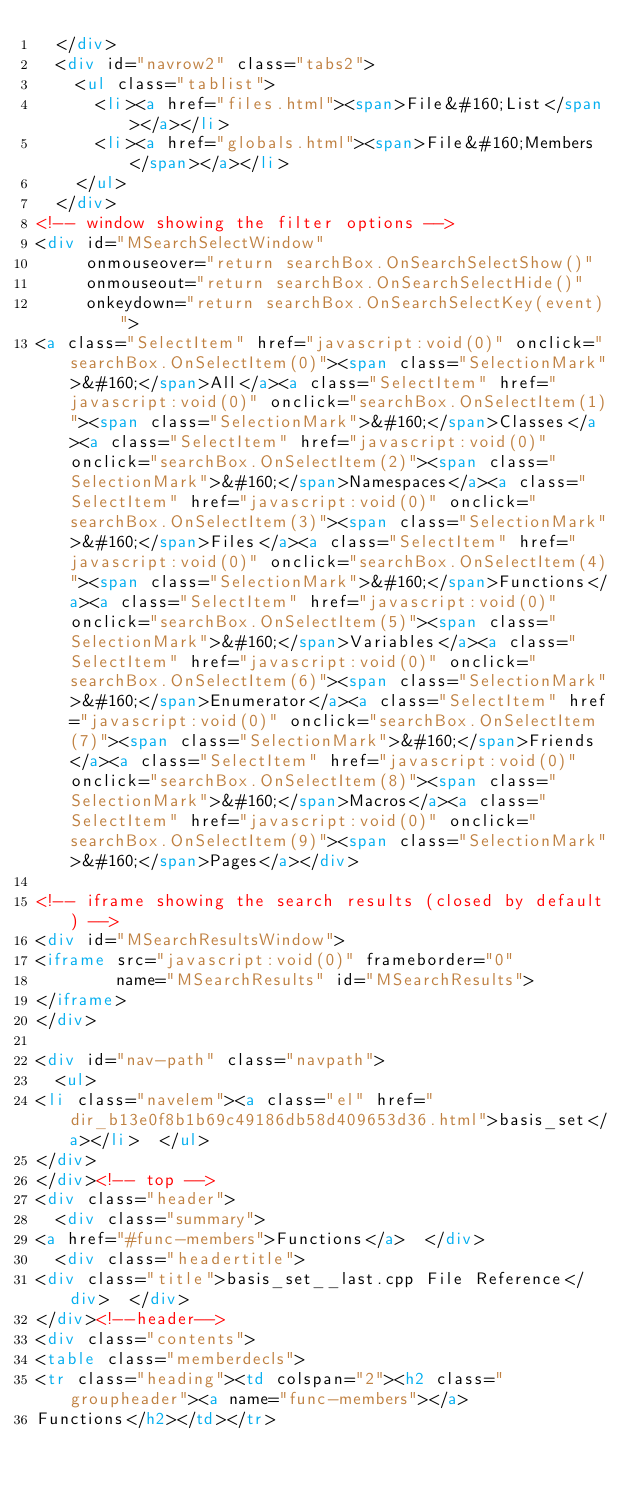<code> <loc_0><loc_0><loc_500><loc_500><_HTML_>  </div>
  <div id="navrow2" class="tabs2">
    <ul class="tablist">
      <li><a href="files.html"><span>File&#160;List</span></a></li>
      <li><a href="globals.html"><span>File&#160;Members</span></a></li>
    </ul>
  </div>
<!-- window showing the filter options -->
<div id="MSearchSelectWindow"
     onmouseover="return searchBox.OnSearchSelectShow()"
     onmouseout="return searchBox.OnSearchSelectHide()"
     onkeydown="return searchBox.OnSearchSelectKey(event)">
<a class="SelectItem" href="javascript:void(0)" onclick="searchBox.OnSelectItem(0)"><span class="SelectionMark">&#160;</span>All</a><a class="SelectItem" href="javascript:void(0)" onclick="searchBox.OnSelectItem(1)"><span class="SelectionMark">&#160;</span>Classes</a><a class="SelectItem" href="javascript:void(0)" onclick="searchBox.OnSelectItem(2)"><span class="SelectionMark">&#160;</span>Namespaces</a><a class="SelectItem" href="javascript:void(0)" onclick="searchBox.OnSelectItem(3)"><span class="SelectionMark">&#160;</span>Files</a><a class="SelectItem" href="javascript:void(0)" onclick="searchBox.OnSelectItem(4)"><span class="SelectionMark">&#160;</span>Functions</a><a class="SelectItem" href="javascript:void(0)" onclick="searchBox.OnSelectItem(5)"><span class="SelectionMark">&#160;</span>Variables</a><a class="SelectItem" href="javascript:void(0)" onclick="searchBox.OnSelectItem(6)"><span class="SelectionMark">&#160;</span>Enumerator</a><a class="SelectItem" href="javascript:void(0)" onclick="searchBox.OnSelectItem(7)"><span class="SelectionMark">&#160;</span>Friends</a><a class="SelectItem" href="javascript:void(0)" onclick="searchBox.OnSelectItem(8)"><span class="SelectionMark">&#160;</span>Macros</a><a class="SelectItem" href="javascript:void(0)" onclick="searchBox.OnSelectItem(9)"><span class="SelectionMark">&#160;</span>Pages</a></div>

<!-- iframe showing the search results (closed by default) -->
<div id="MSearchResultsWindow">
<iframe src="javascript:void(0)" frameborder="0" 
        name="MSearchResults" id="MSearchResults">
</iframe>
</div>

<div id="nav-path" class="navpath">
  <ul>
<li class="navelem"><a class="el" href="dir_b13e0f8b1b69c49186db58d409653d36.html">basis_set</a></li>  </ul>
</div>
</div><!-- top -->
<div class="header">
  <div class="summary">
<a href="#func-members">Functions</a>  </div>
  <div class="headertitle">
<div class="title">basis_set__last.cpp File Reference</div>  </div>
</div><!--header-->
<div class="contents">
<table class="memberdecls">
<tr class="heading"><td colspan="2"><h2 class="groupheader"><a name="func-members"></a>
Functions</h2></td></tr></code> 